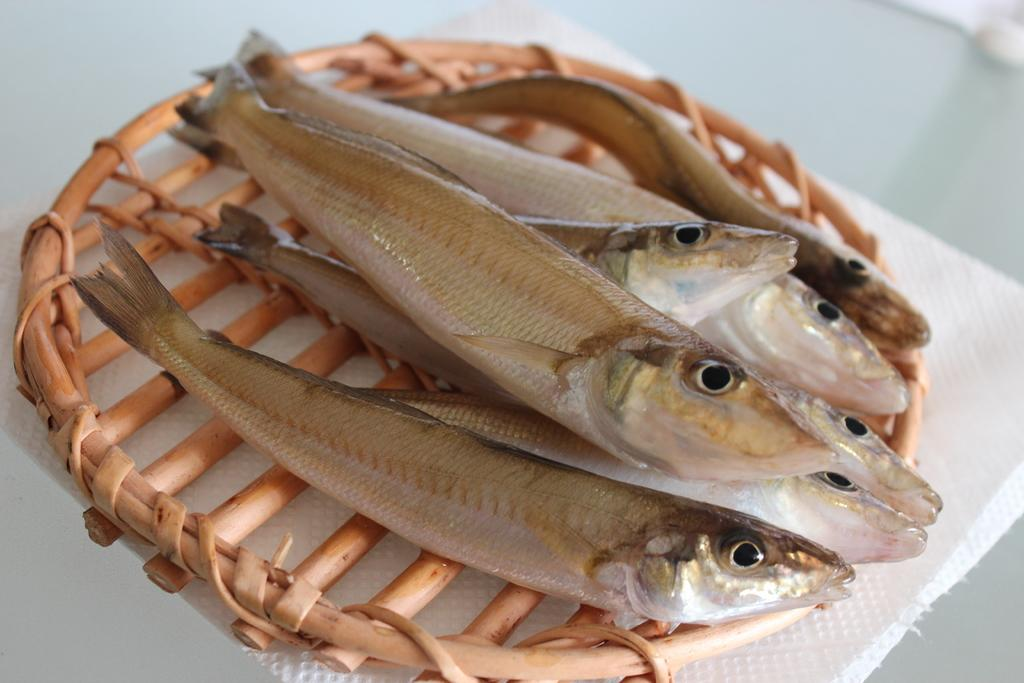What is the main color of the object in the image? The main color of the object in the image is cream. What is depicted on the cream-colored object? There are fishes on the cream-colored object. What is placed under the cream-colored object? There is a white-colored napkin under the cream-colored object. Can you describe the view from the beggar's perspective in the image? There is no beggar present in the image, so it is not possible to describe the view from their perspective. 